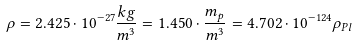Convert formula to latex. <formula><loc_0><loc_0><loc_500><loc_500>\rho = 2 . 4 2 5 \cdot 1 0 ^ { - 2 7 } \frac { k g } { m ^ { 3 } } = 1 . 4 5 0 \cdot \frac { m _ { p } } { m ^ { 3 } } = 4 . 7 0 2 \cdot 1 0 ^ { - 1 2 4 } \rho _ { P l }</formula> 